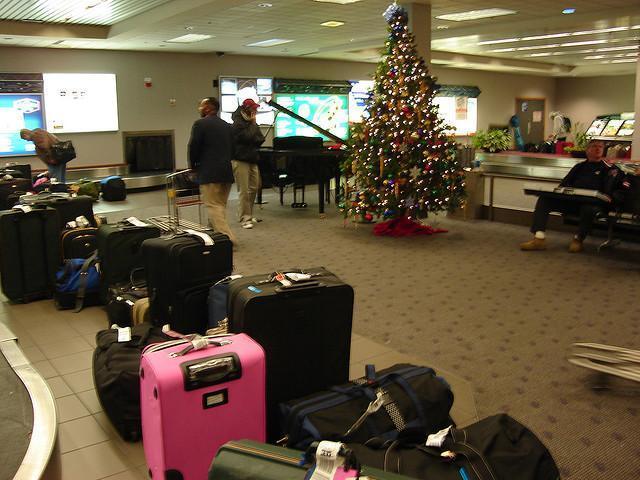How many red tags?
Give a very brief answer. 0. How many backpacks can be seen?
Give a very brief answer. 2. How many suitcases are there?
Give a very brief answer. 8. How many tvs can be seen?
Give a very brief answer. 3. How many people are there?
Give a very brief answer. 3. 